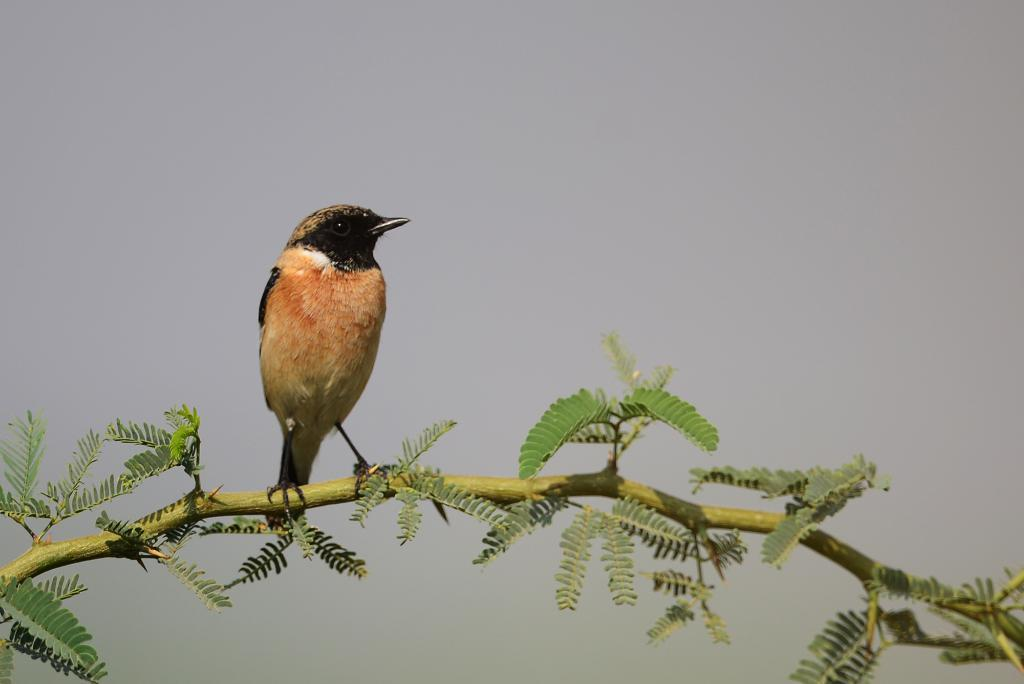Where was the picture taken? The picture was taken outside. What is the main subject in the center of the image? There is a bird in the center of the image. What is the bird standing on? The bird is standing on a branch of a tree. What is the condition of the tree's leaves? The tree has green leaves. What can be seen in the background of the image? The sky is visible in the background of the image. What is the unit arguing about in the image? There is no unit or argument present in the image; it features a bird standing on a tree branch with green leaves. Can you see any fights happening in the image? There are no fights depicted in the image; it shows a bird standing on a tree branch with green leaves and the sky visible in the background. 